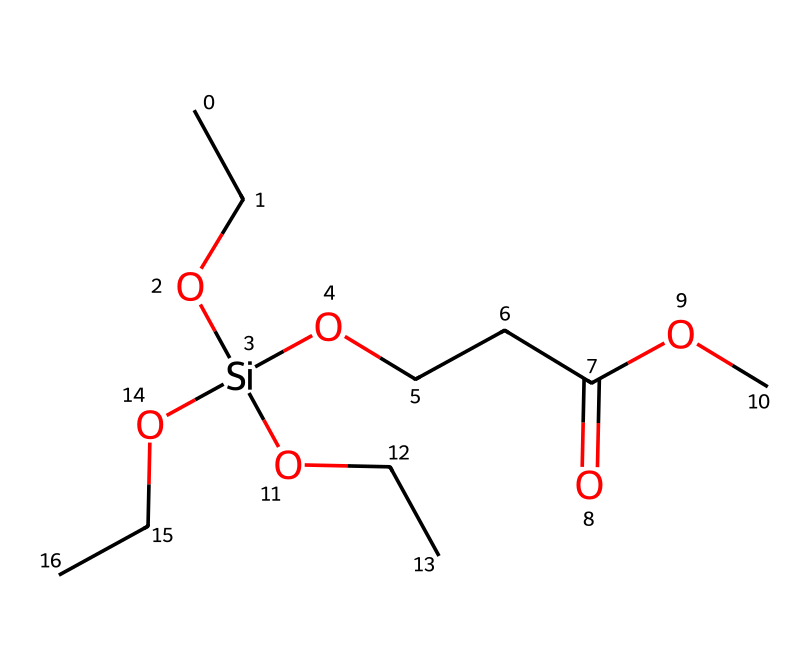What is the molecular formula of the compound in the SMILES? Count the number of each type of atom in the SMILES representation. The compound contains 12 carbon (C), 26 hydrogen (H), 4 oxygen (O), and 1 silicon (Si) atom leading to the molecular formula C12H26O4Si.
Answer: C12H26O4Si How many hydroxyl (–OH) groups are present in the chemical structure? Identify the –OH groups in the SMILES. The structure contains three instances of silicon connected to –O groups that imply hydroxyl functionality.
Answer: three What type of chemical is this compound classified as? Evaluate the presence of silicon in the structure. Since it contains silicon atoms bonded to organic groups, this compound is classified as an organosilicon compound.
Answer: organosilicon compound What functional groups are present in the silane coupling agent? Analyze the SMILES structure to find functional groups. The SMILES shows the presence of ether (–O–), ester (–COO–), and hydroxyl (–OH) groups indicating that these functional groups are part of the structure.
Answer: ether, ester, hydroxyl What is the total number of oxygen atoms in the chemical structure? Count the oxygen atoms in the SMILES representation. There are four oxygen atoms evident from the structure listed.
Answer: four How does the presence of silicon contribute to the properties of this chemical compound? Understand that silicon in the compound provides the ability to bond to inorganic surfaces, enhancing adhesion and water resistance, which is vital for graffiti resistance in paints.
Answer: enhances adhesion and water resistance 